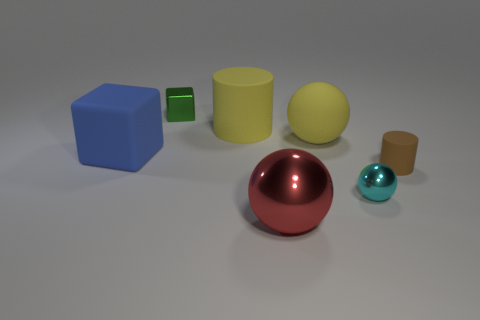How many other objects are there of the same size as the yellow ball?
Offer a very short reply. 3. Do the yellow object that is behind the rubber ball and the small object to the left of the big metal sphere have the same material?
Keep it short and to the point. No. There is a matte cylinder left of the metal ball that is left of the cyan metal object; how big is it?
Offer a very short reply. Large. Are there any large matte cylinders of the same color as the tiny matte cylinder?
Your answer should be compact. No. Do the matte cylinder that is right of the big red metal ball and the large ball in front of the tiny rubber cylinder have the same color?
Ensure brevity in your answer.  No. The small matte thing is what shape?
Offer a very short reply. Cylinder. There is a cyan metal thing; how many large cubes are in front of it?
Make the answer very short. 0. What number of brown cylinders are made of the same material as the tiny cube?
Ensure brevity in your answer.  0. Is the small thing that is on the left side of the large cylinder made of the same material as the tiny brown cylinder?
Provide a succinct answer. No. Are there any large gray matte spheres?
Keep it short and to the point. No. 